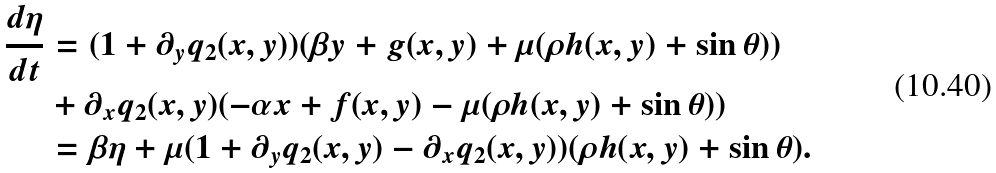Convert formula to latex. <formula><loc_0><loc_0><loc_500><loc_500>\frac { d \eta } { d t } & = ( 1 + \partial _ { y } q _ { 2 } ( x , y ) ) ( \beta y + g ( x , y ) + \mu ( \rho h ( x , y ) + \sin \theta ) ) \\ & + \partial _ { x } q _ { 2 } ( x , y ) ( - \alpha x + f ( x , y ) - \mu ( \rho h ( x , y ) + \sin \theta ) ) \\ & = \beta \eta + \mu ( 1 + \partial _ { y } q _ { 2 } ( x , y ) - \partial _ { x } q _ { 2 } ( x , y ) ) ( \rho h ( x , y ) + \sin \theta ) .</formula> 